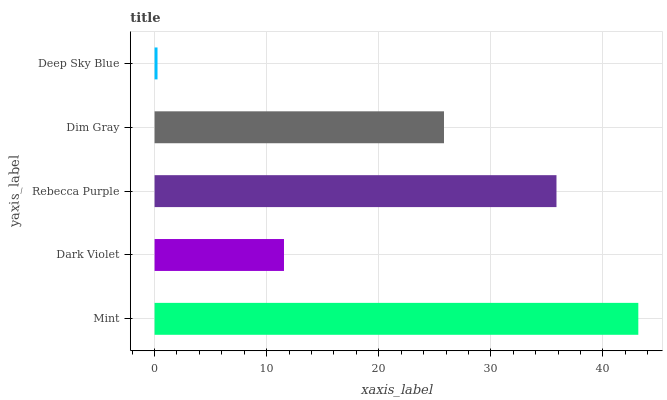Is Deep Sky Blue the minimum?
Answer yes or no. Yes. Is Mint the maximum?
Answer yes or no. Yes. Is Dark Violet the minimum?
Answer yes or no. No. Is Dark Violet the maximum?
Answer yes or no. No. Is Mint greater than Dark Violet?
Answer yes or no. Yes. Is Dark Violet less than Mint?
Answer yes or no. Yes. Is Dark Violet greater than Mint?
Answer yes or no. No. Is Mint less than Dark Violet?
Answer yes or no. No. Is Dim Gray the high median?
Answer yes or no. Yes. Is Dim Gray the low median?
Answer yes or no. Yes. Is Rebecca Purple the high median?
Answer yes or no. No. Is Rebecca Purple the low median?
Answer yes or no. No. 